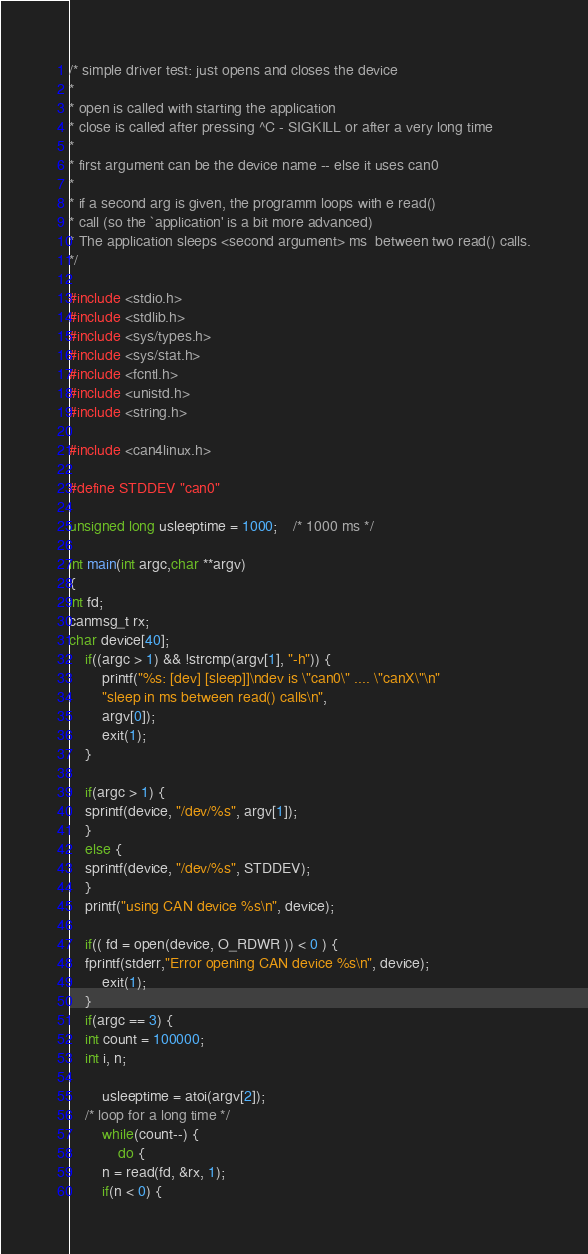Convert code to text. <code><loc_0><loc_0><loc_500><loc_500><_C_>/* simple driver test: just opens and closes the device
* 
* open is called with starting the application
* close is called after pressing ^C - SIGKILL or after a very long time 
*
* first argument can be the device name -- else it uses can0
*
* if a second arg is given, the programm loops with e read()
* call (so the `application' is a bit more advanced)
* The application sleeps <second argument> ms  between two read() calls.
*/

#include <stdio.h>
#include <stdlib.h>
#include <sys/types.h>
#include <sys/stat.h>
#include <fcntl.h>
#include <unistd.h>
#include <string.h>

#include <can4linux.h>

#define STDDEV "can0"

unsigned long usleeptime = 1000;	/* 1000 ms */

int main(int argc,char **argv)
{
int fd;
canmsg_t rx;
char device[40];
    if((argc > 1) && !strcmp(argv[1], "-h")) {
    	printf("%s: [dev] [sleep]]\ndev is \"can0\" .... \"canX\"\n"
    	"sleep in ms between read() calls\n",
    	argv[0]);
    	exit(1);
    }

    if(argc > 1) {
	sprintf(device, "/dev/%s", argv[1]);
    }
    else {
	sprintf(device, "/dev/%s", STDDEV);
    }
    printf("using CAN device %s\n", device);
    
    if(( fd = open(device, O_RDWR )) < 0 ) {
	fprintf(stderr,"Error opening CAN device %s\n", device);
        exit(1);
    }
    if(argc == 3) {
    int count = 100000;
    int i, n;

        usleeptime = atoi(argv[2]);
	/* loop for a long time */
        while(count--) {
            do {
		n = read(fd, &rx, 1);
		if(n < 0) {</code> 